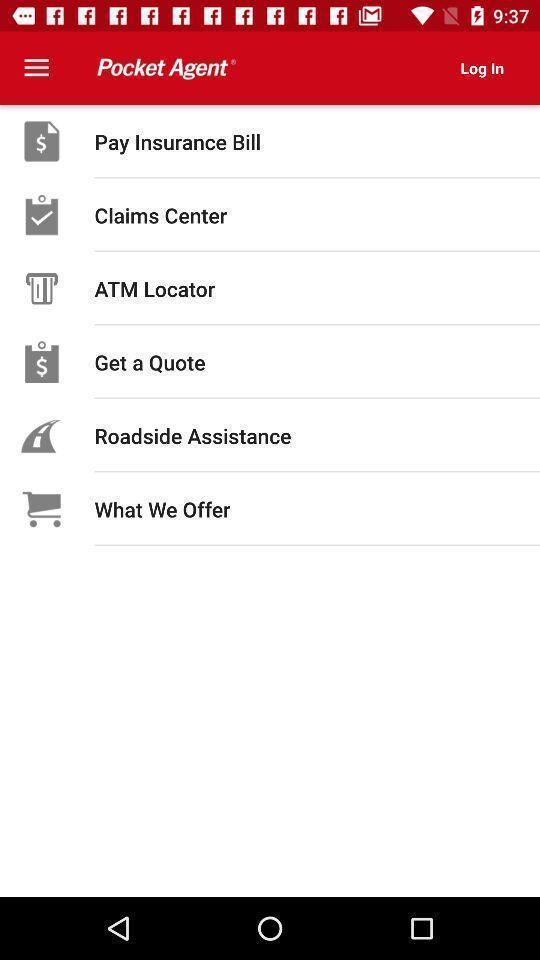Summarize the information in this screenshot. Page displaying various options of insurance. 